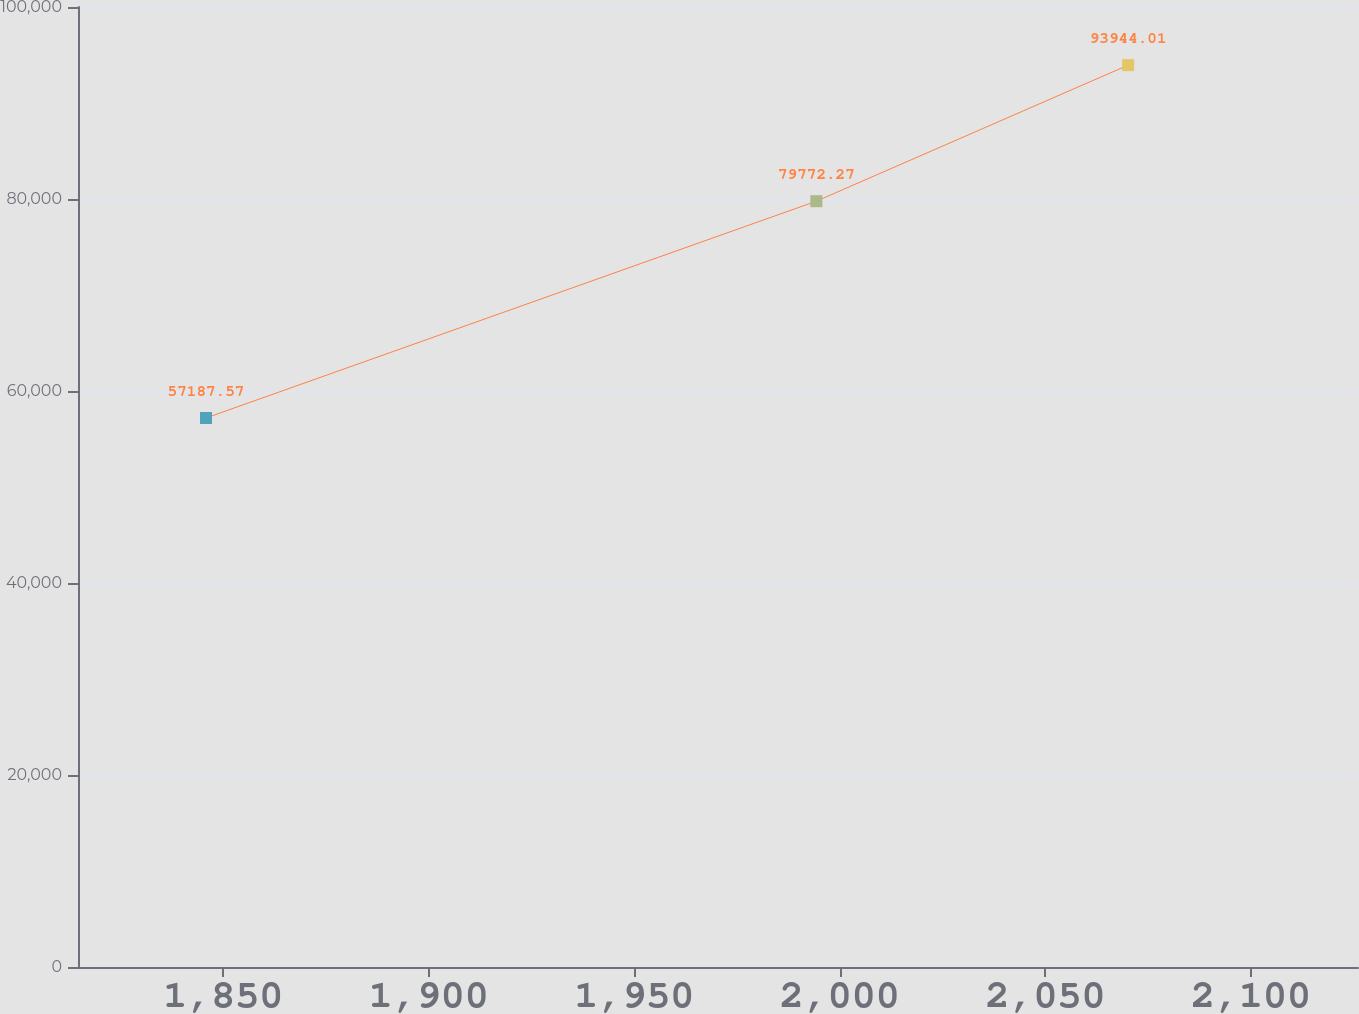Convert chart. <chart><loc_0><loc_0><loc_500><loc_500><line_chart><ecel><fcel>71,767<nl><fcel>1845.81<fcel>57187.6<nl><fcel>1994.29<fcel>79772.3<nl><fcel>2070.13<fcel>93944<nl><fcel>2157.18<fcel>133874<nl></chart> 